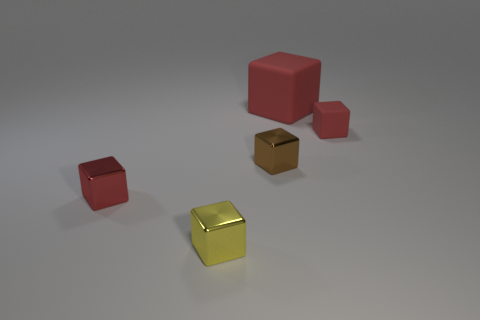Subtract all blue balls. How many red cubes are left? 3 Subtract all small yellow cubes. How many cubes are left? 4 Subtract all brown blocks. How many blocks are left? 4 Subtract all blue cubes. Subtract all green balls. How many cubes are left? 5 Add 2 big purple metal blocks. How many objects exist? 7 Subtract 0 yellow cylinders. How many objects are left? 5 Subtract all large red matte objects. Subtract all tiny yellow metal blocks. How many objects are left? 3 Add 4 tiny metallic cubes. How many tiny metallic cubes are left? 7 Add 1 tiny yellow metallic objects. How many tiny yellow metallic objects exist? 2 